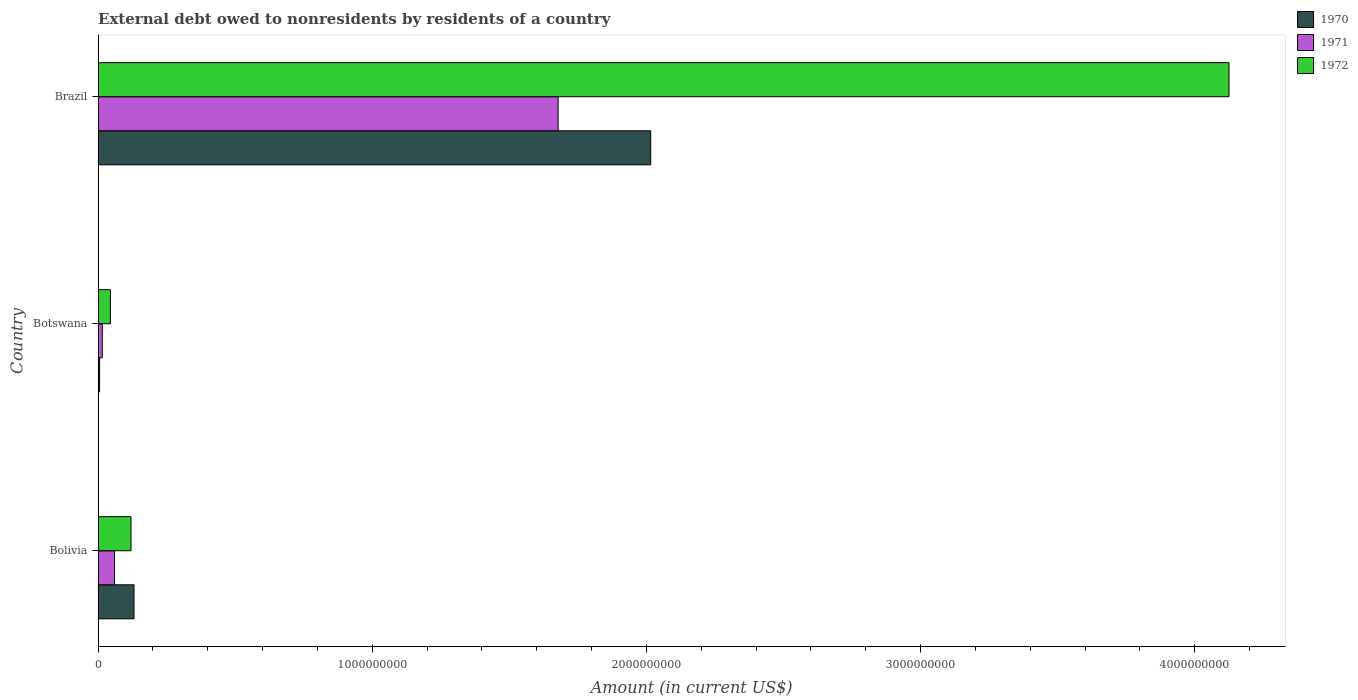How many groups of bars are there?
Your answer should be compact. 3. Are the number of bars on each tick of the Y-axis equal?
Provide a short and direct response. Yes. How many bars are there on the 2nd tick from the bottom?
Provide a short and direct response. 3. What is the external debt owed by residents in 1970 in Botswana?
Your response must be concise. 5.57e+06. Across all countries, what is the maximum external debt owed by residents in 1971?
Your answer should be compact. 1.68e+09. Across all countries, what is the minimum external debt owed by residents in 1972?
Provide a succinct answer. 4.50e+07. In which country was the external debt owed by residents in 1972 minimum?
Offer a terse response. Botswana. What is the total external debt owed by residents in 1971 in the graph?
Your response must be concise. 1.75e+09. What is the difference between the external debt owed by residents in 1970 in Bolivia and that in Botswana?
Your answer should be compact. 1.26e+08. What is the difference between the external debt owed by residents in 1972 in Brazil and the external debt owed by residents in 1970 in Botswana?
Provide a succinct answer. 4.12e+09. What is the average external debt owed by residents in 1972 per country?
Offer a terse response. 1.43e+09. What is the difference between the external debt owed by residents in 1971 and external debt owed by residents in 1970 in Bolivia?
Offer a very short reply. -7.11e+07. In how many countries, is the external debt owed by residents in 1971 greater than 3000000000 US$?
Give a very brief answer. 0. What is the ratio of the external debt owed by residents in 1972 in Bolivia to that in Brazil?
Offer a terse response. 0.03. Is the external debt owed by residents in 1971 in Bolivia less than that in Brazil?
Offer a very short reply. Yes. Is the difference between the external debt owed by residents in 1971 in Bolivia and Botswana greater than the difference between the external debt owed by residents in 1970 in Bolivia and Botswana?
Give a very brief answer. No. What is the difference between the highest and the second highest external debt owed by residents in 1971?
Provide a short and direct response. 1.62e+09. What is the difference between the highest and the lowest external debt owed by residents in 1972?
Your response must be concise. 4.08e+09. In how many countries, is the external debt owed by residents in 1970 greater than the average external debt owed by residents in 1970 taken over all countries?
Make the answer very short. 1. Is the sum of the external debt owed by residents in 1970 in Botswana and Brazil greater than the maximum external debt owed by residents in 1971 across all countries?
Keep it short and to the point. Yes. What does the 3rd bar from the bottom in Brazil represents?
Provide a short and direct response. 1972. What is the difference between two consecutive major ticks on the X-axis?
Your answer should be compact. 1.00e+09. Does the graph contain any zero values?
Offer a terse response. No. Does the graph contain grids?
Provide a short and direct response. No. Where does the legend appear in the graph?
Make the answer very short. Top right. What is the title of the graph?
Keep it short and to the point. External debt owed to nonresidents by residents of a country. What is the Amount (in current US$) in 1970 in Bolivia?
Offer a terse response. 1.31e+08. What is the Amount (in current US$) in 1971 in Bolivia?
Provide a succinct answer. 5.99e+07. What is the Amount (in current US$) in 1972 in Bolivia?
Make the answer very short. 1.20e+08. What is the Amount (in current US$) of 1970 in Botswana?
Your response must be concise. 5.57e+06. What is the Amount (in current US$) of 1971 in Botswana?
Offer a terse response. 1.54e+07. What is the Amount (in current US$) of 1972 in Botswana?
Keep it short and to the point. 4.50e+07. What is the Amount (in current US$) in 1970 in Brazil?
Make the answer very short. 2.02e+09. What is the Amount (in current US$) of 1971 in Brazil?
Make the answer very short. 1.68e+09. What is the Amount (in current US$) in 1972 in Brazil?
Offer a very short reply. 4.13e+09. Across all countries, what is the maximum Amount (in current US$) in 1970?
Offer a terse response. 2.02e+09. Across all countries, what is the maximum Amount (in current US$) of 1971?
Your answer should be very brief. 1.68e+09. Across all countries, what is the maximum Amount (in current US$) in 1972?
Your response must be concise. 4.13e+09. Across all countries, what is the minimum Amount (in current US$) of 1970?
Ensure brevity in your answer.  5.57e+06. Across all countries, what is the minimum Amount (in current US$) in 1971?
Make the answer very short. 1.54e+07. Across all countries, what is the minimum Amount (in current US$) in 1972?
Offer a terse response. 4.50e+07. What is the total Amount (in current US$) of 1970 in the graph?
Give a very brief answer. 2.15e+09. What is the total Amount (in current US$) of 1971 in the graph?
Your answer should be compact. 1.75e+09. What is the total Amount (in current US$) of 1972 in the graph?
Offer a very short reply. 4.29e+09. What is the difference between the Amount (in current US$) in 1970 in Bolivia and that in Botswana?
Provide a succinct answer. 1.26e+08. What is the difference between the Amount (in current US$) of 1971 in Bolivia and that in Botswana?
Provide a short and direct response. 4.45e+07. What is the difference between the Amount (in current US$) in 1972 in Bolivia and that in Botswana?
Offer a very short reply. 7.51e+07. What is the difference between the Amount (in current US$) in 1970 in Bolivia and that in Brazil?
Provide a succinct answer. -1.88e+09. What is the difference between the Amount (in current US$) in 1971 in Bolivia and that in Brazil?
Make the answer very short. -1.62e+09. What is the difference between the Amount (in current US$) in 1972 in Bolivia and that in Brazil?
Offer a very short reply. -4.00e+09. What is the difference between the Amount (in current US$) in 1970 in Botswana and that in Brazil?
Keep it short and to the point. -2.01e+09. What is the difference between the Amount (in current US$) in 1971 in Botswana and that in Brazil?
Your response must be concise. -1.66e+09. What is the difference between the Amount (in current US$) in 1972 in Botswana and that in Brazil?
Make the answer very short. -4.08e+09. What is the difference between the Amount (in current US$) in 1970 in Bolivia and the Amount (in current US$) in 1971 in Botswana?
Make the answer very short. 1.16e+08. What is the difference between the Amount (in current US$) in 1970 in Bolivia and the Amount (in current US$) in 1972 in Botswana?
Your answer should be very brief. 8.61e+07. What is the difference between the Amount (in current US$) of 1971 in Bolivia and the Amount (in current US$) of 1972 in Botswana?
Provide a succinct answer. 1.50e+07. What is the difference between the Amount (in current US$) in 1970 in Bolivia and the Amount (in current US$) in 1971 in Brazil?
Keep it short and to the point. -1.55e+09. What is the difference between the Amount (in current US$) in 1970 in Bolivia and the Amount (in current US$) in 1972 in Brazil?
Your answer should be very brief. -3.99e+09. What is the difference between the Amount (in current US$) in 1971 in Bolivia and the Amount (in current US$) in 1972 in Brazil?
Ensure brevity in your answer.  -4.07e+09. What is the difference between the Amount (in current US$) in 1970 in Botswana and the Amount (in current US$) in 1971 in Brazil?
Provide a short and direct response. -1.67e+09. What is the difference between the Amount (in current US$) in 1970 in Botswana and the Amount (in current US$) in 1972 in Brazil?
Make the answer very short. -4.12e+09. What is the difference between the Amount (in current US$) in 1971 in Botswana and the Amount (in current US$) in 1972 in Brazil?
Make the answer very short. -4.11e+09. What is the average Amount (in current US$) in 1970 per country?
Your answer should be very brief. 7.17e+08. What is the average Amount (in current US$) of 1971 per country?
Keep it short and to the point. 5.84e+08. What is the average Amount (in current US$) in 1972 per country?
Offer a terse response. 1.43e+09. What is the difference between the Amount (in current US$) of 1970 and Amount (in current US$) of 1971 in Bolivia?
Keep it short and to the point. 7.11e+07. What is the difference between the Amount (in current US$) in 1970 and Amount (in current US$) in 1972 in Bolivia?
Make the answer very short. 1.10e+07. What is the difference between the Amount (in current US$) in 1971 and Amount (in current US$) in 1972 in Bolivia?
Give a very brief answer. -6.01e+07. What is the difference between the Amount (in current US$) in 1970 and Amount (in current US$) in 1971 in Botswana?
Keep it short and to the point. -9.82e+06. What is the difference between the Amount (in current US$) of 1970 and Amount (in current US$) of 1972 in Botswana?
Your answer should be compact. -3.94e+07. What is the difference between the Amount (in current US$) of 1971 and Amount (in current US$) of 1972 in Botswana?
Ensure brevity in your answer.  -2.96e+07. What is the difference between the Amount (in current US$) of 1970 and Amount (in current US$) of 1971 in Brazil?
Make the answer very short. 3.38e+08. What is the difference between the Amount (in current US$) of 1970 and Amount (in current US$) of 1972 in Brazil?
Provide a short and direct response. -2.11e+09. What is the difference between the Amount (in current US$) in 1971 and Amount (in current US$) in 1972 in Brazil?
Your response must be concise. -2.45e+09. What is the ratio of the Amount (in current US$) in 1970 in Bolivia to that in Botswana?
Give a very brief answer. 23.55. What is the ratio of the Amount (in current US$) of 1971 in Bolivia to that in Botswana?
Ensure brevity in your answer.  3.89. What is the ratio of the Amount (in current US$) of 1972 in Bolivia to that in Botswana?
Your response must be concise. 2.67. What is the ratio of the Amount (in current US$) of 1970 in Bolivia to that in Brazil?
Make the answer very short. 0.07. What is the ratio of the Amount (in current US$) in 1971 in Bolivia to that in Brazil?
Provide a short and direct response. 0.04. What is the ratio of the Amount (in current US$) in 1972 in Bolivia to that in Brazil?
Your answer should be compact. 0.03. What is the ratio of the Amount (in current US$) in 1970 in Botswana to that in Brazil?
Provide a succinct answer. 0. What is the ratio of the Amount (in current US$) of 1971 in Botswana to that in Brazil?
Your response must be concise. 0.01. What is the ratio of the Amount (in current US$) in 1972 in Botswana to that in Brazil?
Ensure brevity in your answer.  0.01. What is the difference between the highest and the second highest Amount (in current US$) in 1970?
Ensure brevity in your answer.  1.88e+09. What is the difference between the highest and the second highest Amount (in current US$) of 1971?
Ensure brevity in your answer.  1.62e+09. What is the difference between the highest and the second highest Amount (in current US$) in 1972?
Provide a short and direct response. 4.00e+09. What is the difference between the highest and the lowest Amount (in current US$) in 1970?
Give a very brief answer. 2.01e+09. What is the difference between the highest and the lowest Amount (in current US$) of 1971?
Your response must be concise. 1.66e+09. What is the difference between the highest and the lowest Amount (in current US$) of 1972?
Make the answer very short. 4.08e+09. 